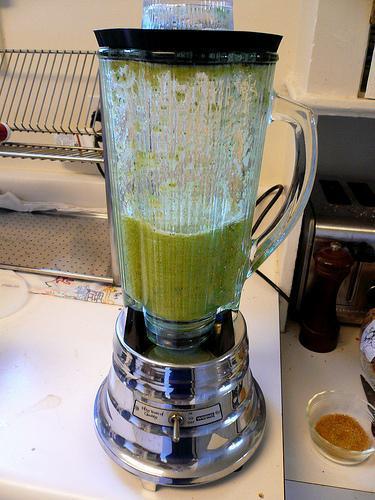How many bowls are in the picture?
Give a very brief answer. 1. 